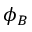Convert formula to latex. <formula><loc_0><loc_0><loc_500><loc_500>\phi _ { B }</formula> 